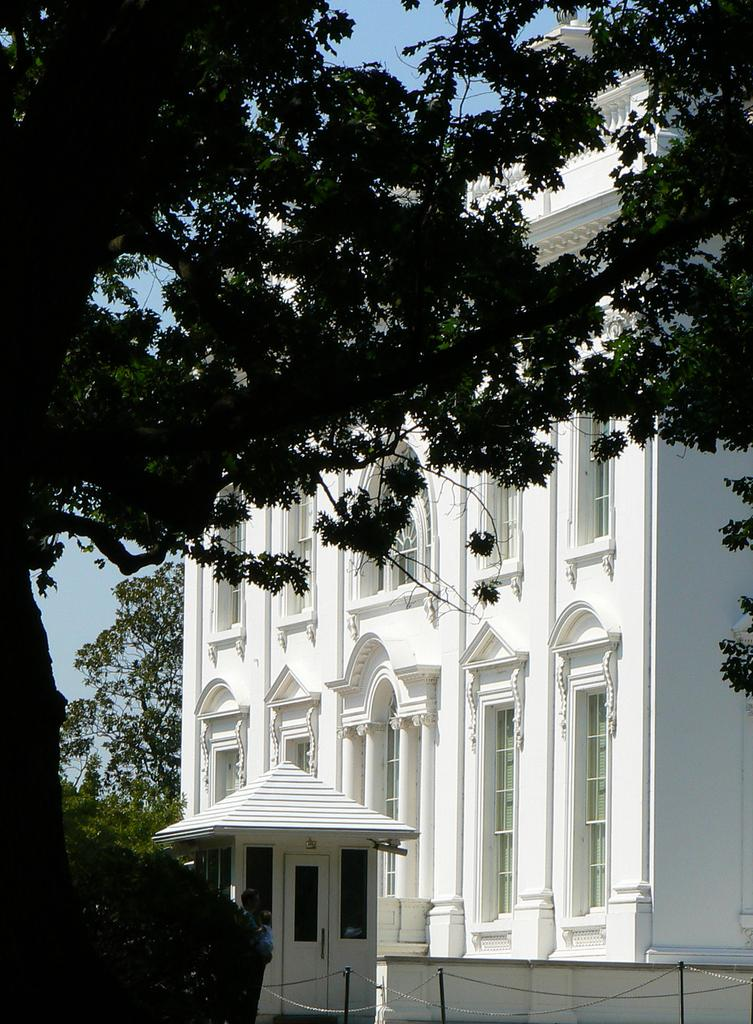What is the color of the building in the image? The building in the image is white. What can be seen on the left side of the image? There are trees on the left side of the image. What is visible at the top of the image? The sky is visible at the top of the image. Can you tell me how many ducks are swimming in the fountain in the image? There is no fountain or ducks present in the image. Is there a donkey visible in the image? No, there is no donkey present in the image. 